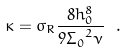Convert formula to latex. <formula><loc_0><loc_0><loc_500><loc_500>\kappa = \sigma _ { R } \frac { 8 h _ { 0 } ^ { 8 } } { 9 { \Sigma _ { 0 } } ^ { 2 } \nu } \ .</formula> 